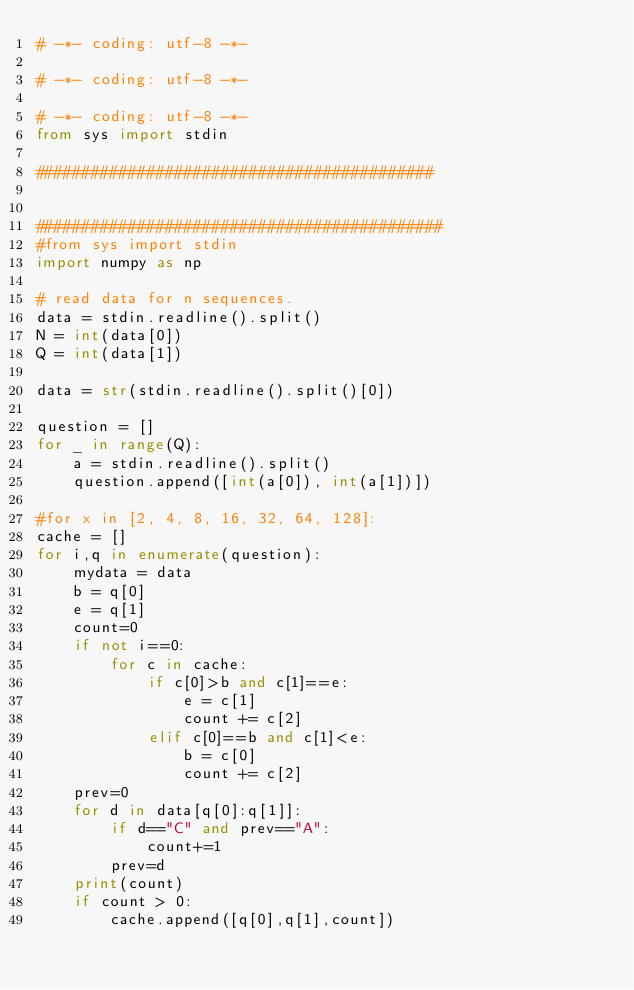Convert code to text. <code><loc_0><loc_0><loc_500><loc_500><_Python_># -*- coding: utf-8 -*-

# -*- coding: utf-8 -*-

# -*- coding: utf-8 -*-
from sys import stdin

###########################################


############################################
#from sys import stdin
import numpy as np

# read data for n sequences.
data = stdin.readline().split()
N = int(data[0])
Q = int(data[1])

data = str(stdin.readline().split()[0])

question = []
for _ in range(Q):
    a = stdin.readline().split()
    question.append([int(a[0]), int(a[1])])
    
#for x in [2, 4, 8, 16, 32, 64, 128]:
cache = []
for i,q in enumerate(question):
    mydata = data
    b = q[0]
    e = q[1]
    count=0    
    if not i==0:
        for c in cache:
            if c[0]>b and c[1]==e:
                e = c[1]
                count += c[2]
            elif c[0]==b and c[1]<e:
                b = c[0]
                count += c[2]                
    prev=0
    for d in data[q[0]:q[1]]:
        if d=="C" and prev=="A":
            count+=1
        prev=d
    print(count)
    if count > 0:
        cache.append([q[0],q[1],count])
    </code> 